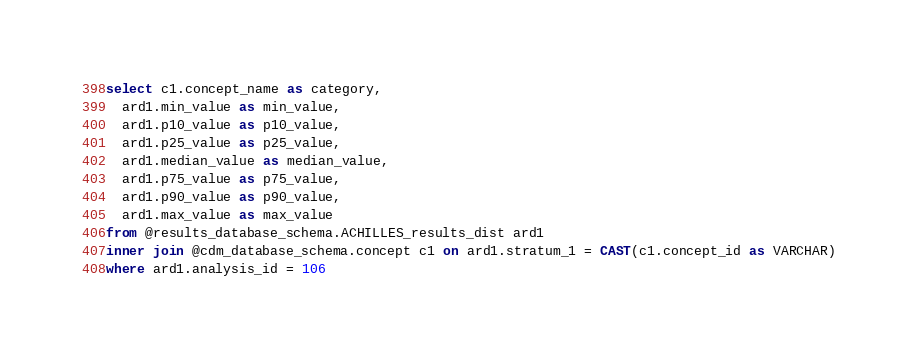<code> <loc_0><loc_0><loc_500><loc_500><_SQL_>select c1.concept_name as category,
  ard1.min_value as min_value,
  ard1.p10_value as p10_value,
  ard1.p25_value as p25_value,
  ard1.median_value as median_value,
  ard1.p75_value as p75_value,
  ard1.p90_value as p90_value,
  ard1.max_value as max_value
from @results_database_schema.ACHILLES_results_dist ard1
inner join @cdm_database_schema.concept c1 on ard1.stratum_1 = CAST(c1.concept_id as VARCHAR)
where ard1.analysis_id = 106</code> 